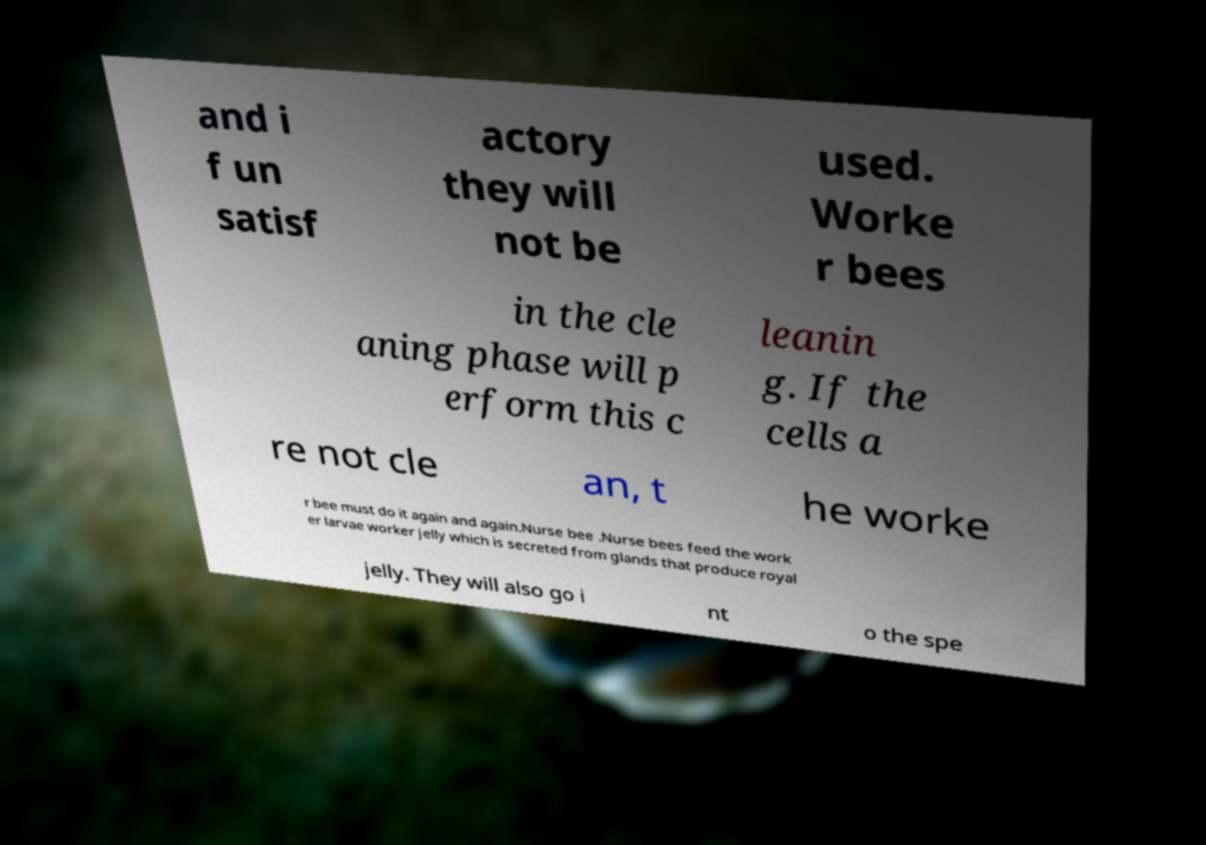Please read and relay the text visible in this image. What does it say? and i f un satisf actory they will not be used. Worke r bees in the cle aning phase will p erform this c leanin g. If the cells a re not cle an, t he worke r bee must do it again and again.Nurse bee .Nurse bees feed the work er larvae worker jelly which is secreted from glands that produce royal jelly. They will also go i nt o the spe 